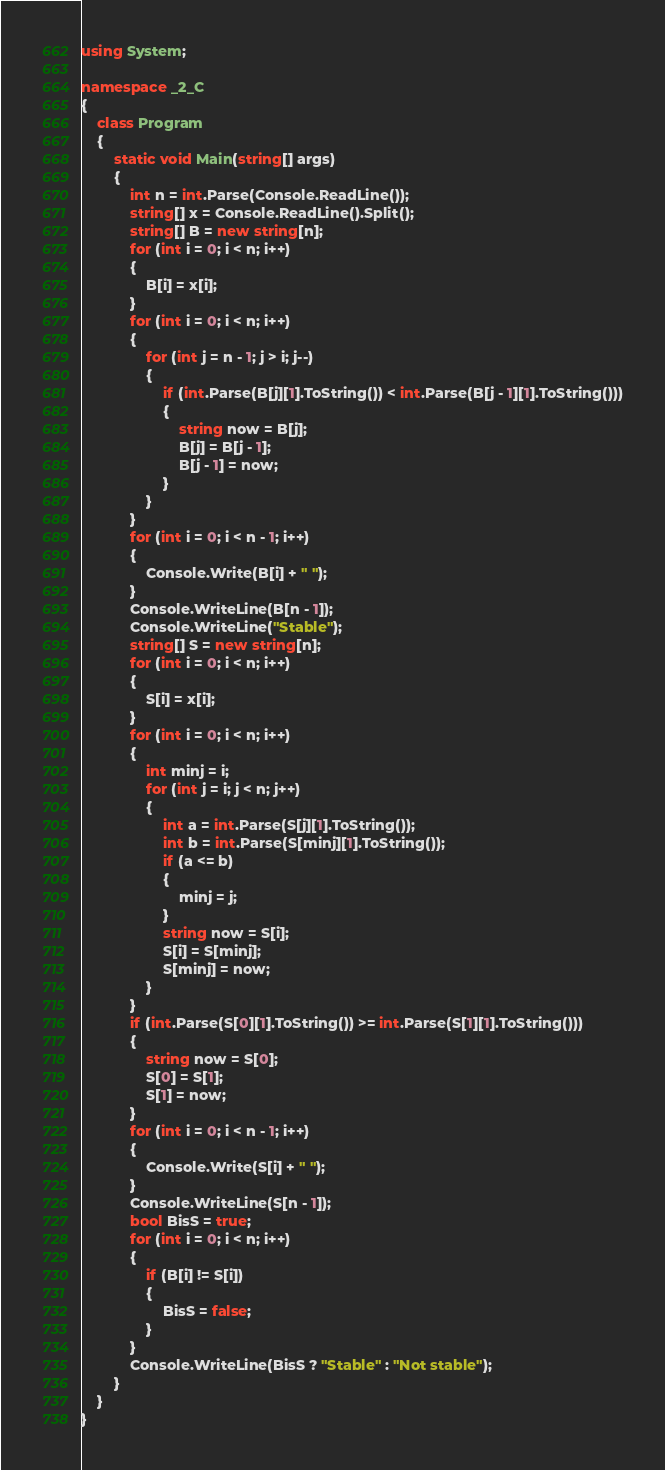Convert code to text. <code><loc_0><loc_0><loc_500><loc_500><_C#_>using System;

namespace _2_C
{
    class Program
    {
        static void Main(string[] args)
        {
            int n = int.Parse(Console.ReadLine());
            string[] x = Console.ReadLine().Split();
            string[] B = new string[n];
            for (int i = 0; i < n; i++)
            {
                B[i] = x[i];
            }
            for (int i = 0; i < n; i++)
            {
                for (int j = n - 1; j > i; j--)
                {
                    if (int.Parse(B[j][1].ToString()) < int.Parse(B[j - 1][1].ToString()))
                    {
                        string now = B[j];
                        B[j] = B[j - 1];
                        B[j - 1] = now;
                    }
                }
            }
            for (int i = 0; i < n - 1; i++)
            {
                Console.Write(B[i] + " ");
            }
            Console.WriteLine(B[n - 1]);
            Console.WriteLine("Stable");
            string[] S = new string[n];
            for (int i = 0; i < n; i++)
            {
                S[i] = x[i];
            }
            for (int i = 0; i < n; i++)
            {
                int minj = i;
                for (int j = i; j < n; j++)
                {
                    int a = int.Parse(S[j][1].ToString());
                    int b = int.Parse(S[minj][1].ToString());
                    if (a <= b)
                    {
                        minj = j;
                    }
                    string now = S[i];
                    S[i] = S[minj];
                    S[minj] = now;
                }
            }
            if (int.Parse(S[0][1].ToString()) >= int.Parse(S[1][1].ToString()))
            {
                string now = S[0];
                S[0] = S[1];
                S[1] = now;
            }
            for (int i = 0; i < n - 1; i++)
            {
                Console.Write(S[i] + " ");
            }
            Console.WriteLine(S[n - 1]);
            bool BisS = true;
            for (int i = 0; i < n; i++)
            {
                if (B[i] != S[i])
                {
                    BisS = false;
                }
            }
            Console.WriteLine(BisS ? "Stable" : "Not stable");
        }
    }
}</code> 